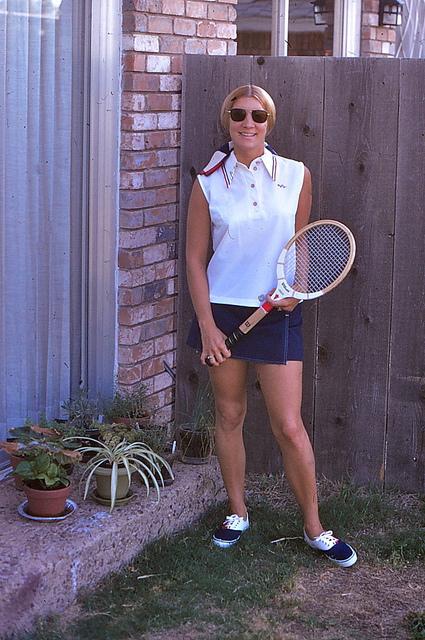How old is the woman?
Give a very brief answer. 35. Is the woman inside or outside?
Quick response, please. Outside. Did the woman come from playing tennis or is she going to play tennis?
Concise answer only. Going. 